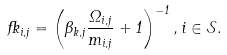<formula> <loc_0><loc_0><loc_500><loc_500>\Psi _ { i , j } = \left ( \beta _ { k , j } \frac { \Omega _ { i , j } } { m _ { i , j } } + 1 \right ) ^ { - 1 } , i \in \mathcal { S } .</formula> 